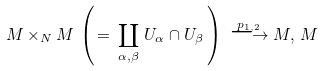<formula> <loc_0><loc_0><loc_500><loc_500>M \times _ { N } M \, \left ( \, = \, \coprod _ { \alpha , \beta } \, U _ { \alpha } \cap U _ { \beta } \, \right ) \, \stackrel { p _ { 1 , 2 } } { \longrightarrow } M , \, M</formula> 